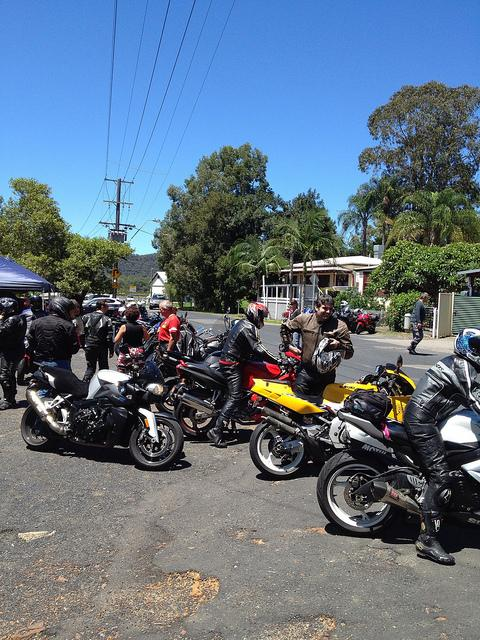What type weather is typical here? Please explain your reasoning. tropical. It's the only answer that's most likely. the other options wouldn't have the green trees in the background. 